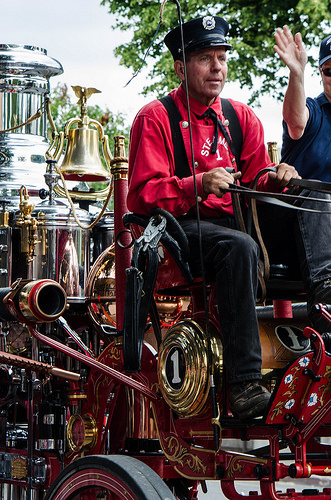<image>
Is the bell on the trolley? Yes. Looking at the image, I can see the bell is positioned on top of the trolley, with the trolley providing support. 